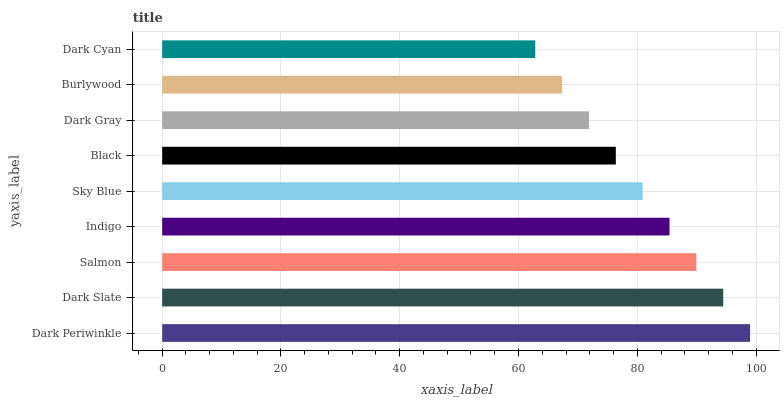Is Dark Cyan the minimum?
Answer yes or no. Yes. Is Dark Periwinkle the maximum?
Answer yes or no. Yes. Is Dark Slate the minimum?
Answer yes or no. No. Is Dark Slate the maximum?
Answer yes or no. No. Is Dark Periwinkle greater than Dark Slate?
Answer yes or no. Yes. Is Dark Slate less than Dark Periwinkle?
Answer yes or no. Yes. Is Dark Slate greater than Dark Periwinkle?
Answer yes or no. No. Is Dark Periwinkle less than Dark Slate?
Answer yes or no. No. Is Sky Blue the high median?
Answer yes or no. Yes. Is Sky Blue the low median?
Answer yes or no. Yes. Is Indigo the high median?
Answer yes or no. No. Is Salmon the low median?
Answer yes or no. No. 